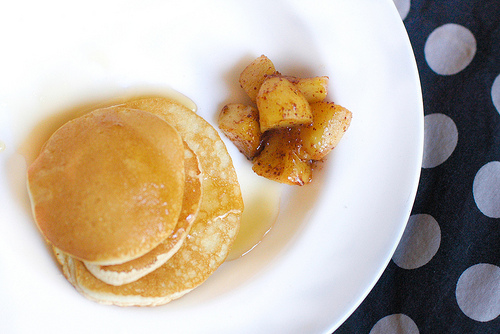<image>
Can you confirm if the apples is on the pancakes? No. The apples is not positioned on the pancakes. They may be near each other, but the apples is not supported by or resting on top of the pancakes. Where is the cloth in relation to the potato? Is it to the left of the potato? No. The cloth is not to the left of the potato. From this viewpoint, they have a different horizontal relationship. 